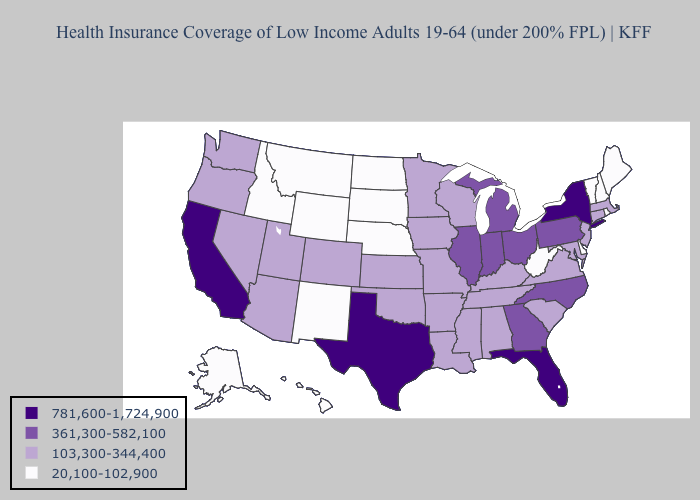Name the states that have a value in the range 361,300-582,100?
Be succinct. Georgia, Illinois, Indiana, Michigan, North Carolina, Ohio, Pennsylvania. Among the states that border Oregon , which have the highest value?
Be succinct. California. Does the first symbol in the legend represent the smallest category?
Keep it brief. No. What is the value of Kentucky?
Short answer required. 103,300-344,400. Which states have the lowest value in the Northeast?
Keep it brief. Maine, New Hampshire, Rhode Island, Vermont. How many symbols are there in the legend?
Concise answer only. 4. What is the value of West Virginia?
Quick response, please. 20,100-102,900. What is the value of Texas?
Keep it brief. 781,600-1,724,900. Does the first symbol in the legend represent the smallest category?
Give a very brief answer. No. What is the value of Oregon?
Be succinct. 103,300-344,400. Does Nebraska have the lowest value in the USA?
Write a very short answer. Yes. What is the value of Indiana?
Write a very short answer. 361,300-582,100. Does the first symbol in the legend represent the smallest category?
Concise answer only. No. Does the map have missing data?
Write a very short answer. No. Name the states that have a value in the range 781,600-1,724,900?
Quick response, please. California, Florida, New York, Texas. 